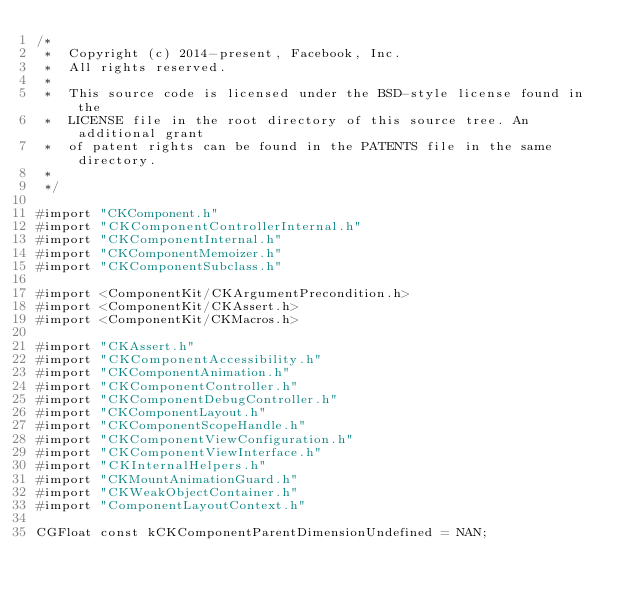<code> <loc_0><loc_0><loc_500><loc_500><_ObjectiveC_>/*
 *  Copyright (c) 2014-present, Facebook, Inc.
 *  All rights reserved.
 *
 *  This source code is licensed under the BSD-style license found in the
 *  LICENSE file in the root directory of this source tree. An additional grant
 *  of patent rights can be found in the PATENTS file in the same directory.
 *
 */

#import "CKComponent.h"
#import "CKComponentControllerInternal.h"
#import "CKComponentInternal.h"
#import "CKComponentMemoizer.h"
#import "CKComponentSubclass.h"

#import <ComponentKit/CKArgumentPrecondition.h>
#import <ComponentKit/CKAssert.h>
#import <ComponentKit/CKMacros.h>

#import "CKAssert.h"
#import "CKComponentAccessibility.h"
#import "CKComponentAnimation.h"
#import "CKComponentController.h"
#import "CKComponentDebugController.h"
#import "CKComponentLayout.h"
#import "CKComponentScopeHandle.h"
#import "CKComponentViewConfiguration.h"
#import "CKComponentViewInterface.h"
#import "CKInternalHelpers.h"
#import "CKMountAnimationGuard.h"
#import "CKWeakObjectContainer.h"
#import "ComponentLayoutContext.h"

CGFloat const kCKComponentParentDimensionUndefined = NAN;</code> 